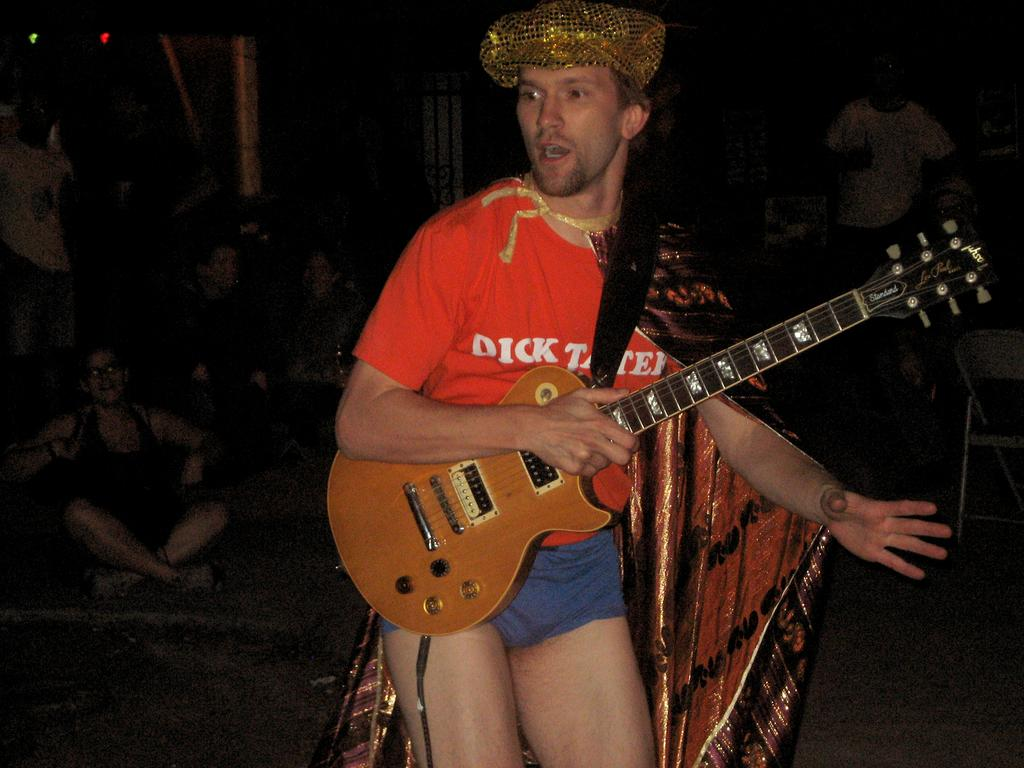What is the main subject of the image? There is a man in the image. What is the man holding in the image? The man is holding a guitar. What type of reaction can be seen from the cobweb in the image? There is no cobweb present in the image, so it is not possible to determine any reaction from it. 